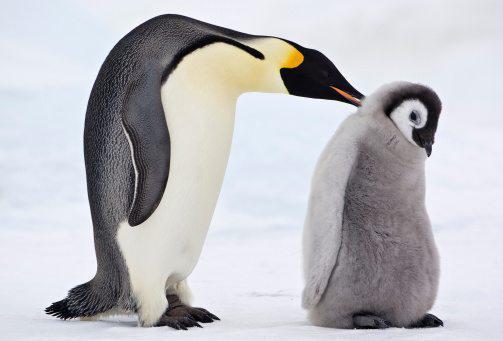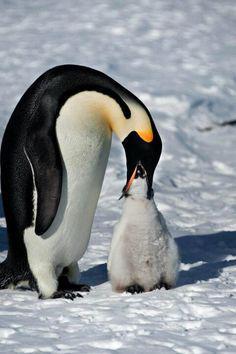The first image is the image on the left, the second image is the image on the right. Analyze the images presented: Is the assertion "An image shows a penguin poking its mostly closed beak in the fuzzy feathers of another penguin." valid? Answer yes or no. Yes. 